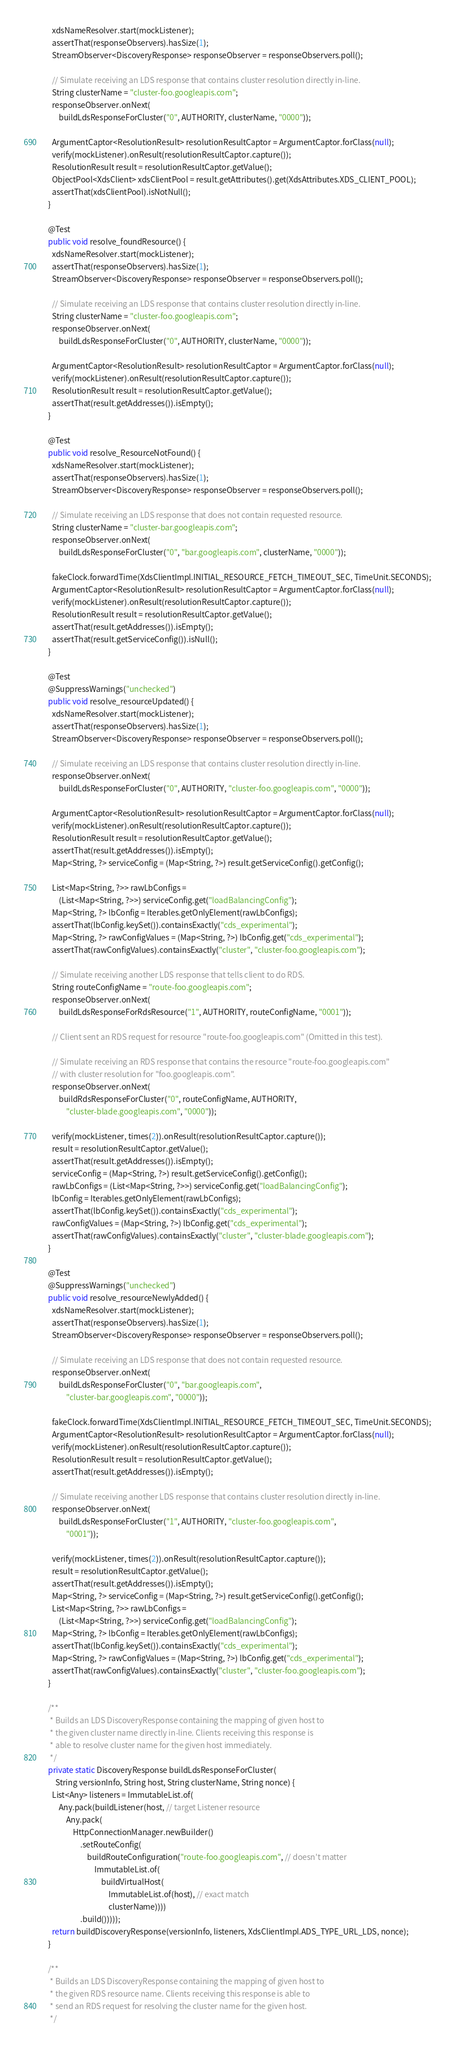Convert code to text. <code><loc_0><loc_0><loc_500><loc_500><_Java_>    xdsNameResolver.start(mockListener);
    assertThat(responseObservers).hasSize(1);
    StreamObserver<DiscoveryResponse> responseObserver = responseObservers.poll();

    // Simulate receiving an LDS response that contains cluster resolution directly in-line.
    String clusterName = "cluster-foo.googleapis.com";
    responseObserver.onNext(
        buildLdsResponseForCluster("0", AUTHORITY, clusterName, "0000"));

    ArgumentCaptor<ResolutionResult> resolutionResultCaptor = ArgumentCaptor.forClass(null);
    verify(mockListener).onResult(resolutionResultCaptor.capture());
    ResolutionResult result = resolutionResultCaptor.getValue();
    ObjectPool<XdsClient> xdsClientPool = result.getAttributes().get(XdsAttributes.XDS_CLIENT_POOL);
    assertThat(xdsClientPool).isNotNull();
  }

  @Test
  public void resolve_foundResource() {
    xdsNameResolver.start(mockListener);
    assertThat(responseObservers).hasSize(1);
    StreamObserver<DiscoveryResponse> responseObserver = responseObservers.poll();

    // Simulate receiving an LDS response that contains cluster resolution directly in-line.
    String clusterName = "cluster-foo.googleapis.com";
    responseObserver.onNext(
        buildLdsResponseForCluster("0", AUTHORITY, clusterName, "0000"));

    ArgumentCaptor<ResolutionResult> resolutionResultCaptor = ArgumentCaptor.forClass(null);
    verify(mockListener).onResult(resolutionResultCaptor.capture());
    ResolutionResult result = resolutionResultCaptor.getValue();
    assertThat(result.getAddresses()).isEmpty();
  }

  @Test
  public void resolve_ResourceNotFound() {
    xdsNameResolver.start(mockListener);
    assertThat(responseObservers).hasSize(1);
    StreamObserver<DiscoveryResponse> responseObserver = responseObservers.poll();

    // Simulate receiving an LDS response that does not contain requested resource.
    String clusterName = "cluster-bar.googleapis.com";
    responseObserver.onNext(
        buildLdsResponseForCluster("0", "bar.googleapis.com", clusterName, "0000"));

    fakeClock.forwardTime(XdsClientImpl.INITIAL_RESOURCE_FETCH_TIMEOUT_SEC, TimeUnit.SECONDS);
    ArgumentCaptor<ResolutionResult> resolutionResultCaptor = ArgumentCaptor.forClass(null);
    verify(mockListener).onResult(resolutionResultCaptor.capture());
    ResolutionResult result = resolutionResultCaptor.getValue();
    assertThat(result.getAddresses()).isEmpty();
    assertThat(result.getServiceConfig()).isNull();
  }

  @Test
  @SuppressWarnings("unchecked")
  public void resolve_resourceUpdated() {
    xdsNameResolver.start(mockListener);
    assertThat(responseObservers).hasSize(1);
    StreamObserver<DiscoveryResponse> responseObserver = responseObservers.poll();

    // Simulate receiving an LDS response that contains cluster resolution directly in-line.
    responseObserver.onNext(
        buildLdsResponseForCluster("0", AUTHORITY, "cluster-foo.googleapis.com", "0000"));

    ArgumentCaptor<ResolutionResult> resolutionResultCaptor = ArgumentCaptor.forClass(null);
    verify(mockListener).onResult(resolutionResultCaptor.capture());
    ResolutionResult result = resolutionResultCaptor.getValue();
    assertThat(result.getAddresses()).isEmpty();
    Map<String, ?> serviceConfig = (Map<String, ?>) result.getServiceConfig().getConfig();

    List<Map<String, ?>> rawLbConfigs =
        (List<Map<String, ?>>) serviceConfig.get("loadBalancingConfig");
    Map<String, ?> lbConfig = Iterables.getOnlyElement(rawLbConfigs);
    assertThat(lbConfig.keySet()).containsExactly("cds_experimental");
    Map<String, ?> rawConfigValues = (Map<String, ?>) lbConfig.get("cds_experimental");
    assertThat(rawConfigValues).containsExactly("cluster", "cluster-foo.googleapis.com");

    // Simulate receiving another LDS response that tells client to do RDS.
    String routeConfigName = "route-foo.googleapis.com";
    responseObserver.onNext(
        buildLdsResponseForRdsResource("1", AUTHORITY, routeConfigName, "0001"));

    // Client sent an RDS request for resource "route-foo.googleapis.com" (Omitted in this test).

    // Simulate receiving an RDS response that contains the resource "route-foo.googleapis.com"
    // with cluster resolution for "foo.googleapis.com".
    responseObserver.onNext(
        buildRdsResponseForCluster("0", routeConfigName, AUTHORITY,
            "cluster-blade.googleapis.com", "0000"));

    verify(mockListener, times(2)).onResult(resolutionResultCaptor.capture());
    result = resolutionResultCaptor.getValue();
    assertThat(result.getAddresses()).isEmpty();
    serviceConfig = (Map<String, ?>) result.getServiceConfig().getConfig();
    rawLbConfigs = (List<Map<String, ?>>) serviceConfig.get("loadBalancingConfig");
    lbConfig = Iterables.getOnlyElement(rawLbConfigs);
    assertThat(lbConfig.keySet()).containsExactly("cds_experimental");
    rawConfigValues = (Map<String, ?>) lbConfig.get("cds_experimental");
    assertThat(rawConfigValues).containsExactly("cluster", "cluster-blade.googleapis.com");
  }

  @Test
  @SuppressWarnings("unchecked")
  public void resolve_resourceNewlyAdded() {
    xdsNameResolver.start(mockListener);
    assertThat(responseObservers).hasSize(1);
    StreamObserver<DiscoveryResponse> responseObserver = responseObservers.poll();

    // Simulate receiving an LDS response that does not contain requested resource.
    responseObserver.onNext(
        buildLdsResponseForCluster("0", "bar.googleapis.com",
            "cluster-bar.googleapis.com", "0000"));

    fakeClock.forwardTime(XdsClientImpl.INITIAL_RESOURCE_FETCH_TIMEOUT_SEC, TimeUnit.SECONDS);
    ArgumentCaptor<ResolutionResult> resolutionResultCaptor = ArgumentCaptor.forClass(null);
    verify(mockListener).onResult(resolutionResultCaptor.capture());
    ResolutionResult result = resolutionResultCaptor.getValue();
    assertThat(result.getAddresses()).isEmpty();

    // Simulate receiving another LDS response that contains cluster resolution directly in-line.
    responseObserver.onNext(
        buildLdsResponseForCluster("1", AUTHORITY, "cluster-foo.googleapis.com",
            "0001"));

    verify(mockListener, times(2)).onResult(resolutionResultCaptor.capture());
    result = resolutionResultCaptor.getValue();
    assertThat(result.getAddresses()).isEmpty();
    Map<String, ?> serviceConfig = (Map<String, ?>) result.getServiceConfig().getConfig();
    List<Map<String, ?>> rawLbConfigs =
        (List<Map<String, ?>>) serviceConfig.get("loadBalancingConfig");
    Map<String, ?> lbConfig = Iterables.getOnlyElement(rawLbConfigs);
    assertThat(lbConfig.keySet()).containsExactly("cds_experimental");
    Map<String, ?> rawConfigValues = (Map<String, ?>) lbConfig.get("cds_experimental");
    assertThat(rawConfigValues).containsExactly("cluster", "cluster-foo.googleapis.com");
  }

  /**
   * Builds an LDS DiscoveryResponse containing the mapping of given host to
   * the given cluster name directly in-line. Clients receiving this response is
   * able to resolve cluster name for the given host immediately.
   */
  private static DiscoveryResponse buildLdsResponseForCluster(
      String versionInfo, String host, String clusterName, String nonce) {
    List<Any> listeners = ImmutableList.of(
        Any.pack(buildListener(host, // target Listener resource
            Any.pack(
                HttpConnectionManager.newBuilder()
                    .setRouteConfig(
                        buildRouteConfiguration("route-foo.googleapis.com", // doesn't matter
                            ImmutableList.of(
                                buildVirtualHost(
                                    ImmutableList.of(host), // exact match
                                    clusterName))))
                    .build()))));
    return buildDiscoveryResponse(versionInfo, listeners, XdsClientImpl.ADS_TYPE_URL_LDS, nonce);
  }

  /**
   * Builds an LDS DiscoveryResponse containing the mapping of given host to
   * the given RDS resource name. Clients receiving this response is able to
   * send an RDS request for resolving the cluster name for the given host.
   */</code> 